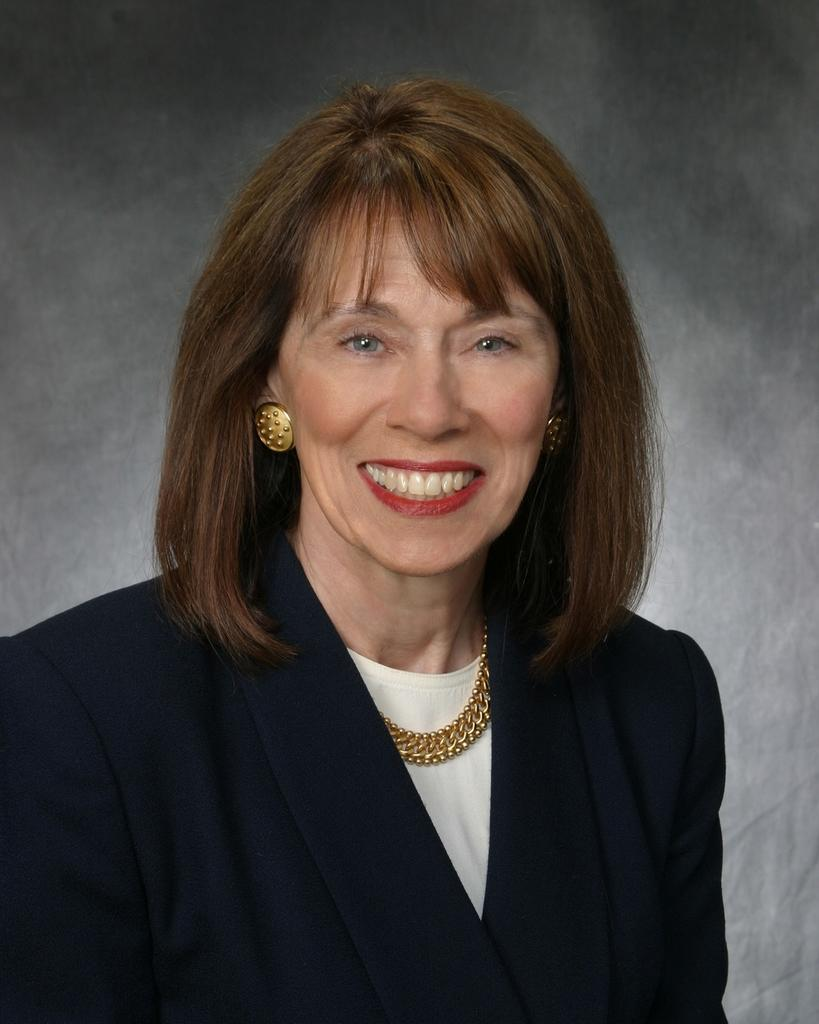Who is the main subject in the image? There is a lady in the image. What is the lady wearing in the image? The lady is wearing a black coat and a gold chain. What type of drug is the lady holding in the image? There is no drug present in the image; the lady is wearing a black coat and a gold chain. 